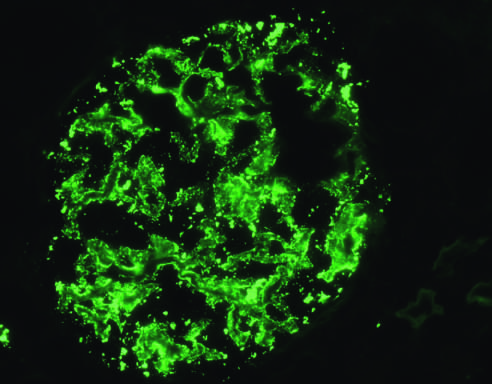what is deposition of igg antibody in a granular pattern detected by?
Answer the question using a single word or phrase. Immunofluorescence 